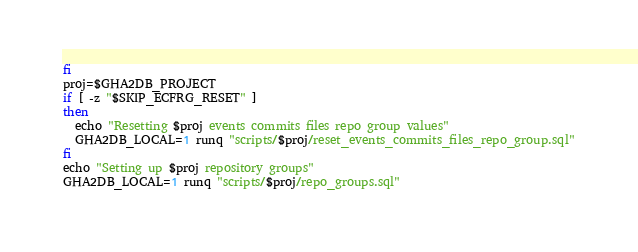<code> <loc_0><loc_0><loc_500><loc_500><_Bash_>fi
proj=$GHA2DB_PROJECT
if [ -z "$SKIP_ECFRG_RESET" ]
then
  echo "Resetting $proj events commits files repo group values"
  GHA2DB_LOCAL=1 runq "scripts/$proj/reset_events_commits_files_repo_group.sql"
fi
echo "Setting up $proj repository groups"
GHA2DB_LOCAL=1 runq "scripts/$proj/repo_groups.sql"
</code> 